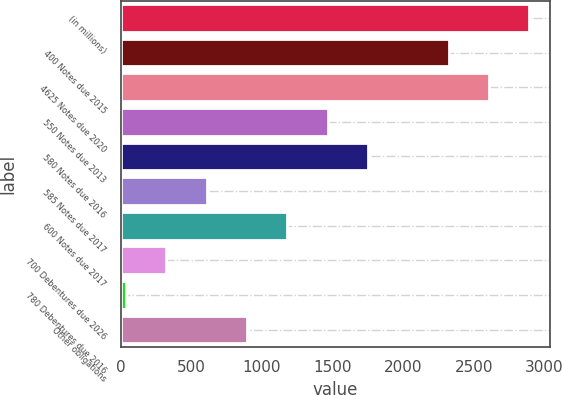Convert chart. <chart><loc_0><loc_0><loc_500><loc_500><bar_chart><fcel>(in millions)<fcel>400 Notes due 2015<fcel>4625 Notes due 2020<fcel>550 Notes due 2013<fcel>580 Notes due 2016<fcel>585 Notes due 2017<fcel>600 Notes due 2017<fcel>700 Debentures due 2026<fcel>780 Debentures due 2016<fcel>Other obligations<nl><fcel>2894<fcel>2322.6<fcel>2608.3<fcel>1465.5<fcel>1751.2<fcel>608.4<fcel>1179.8<fcel>322.7<fcel>37<fcel>894.1<nl></chart> 